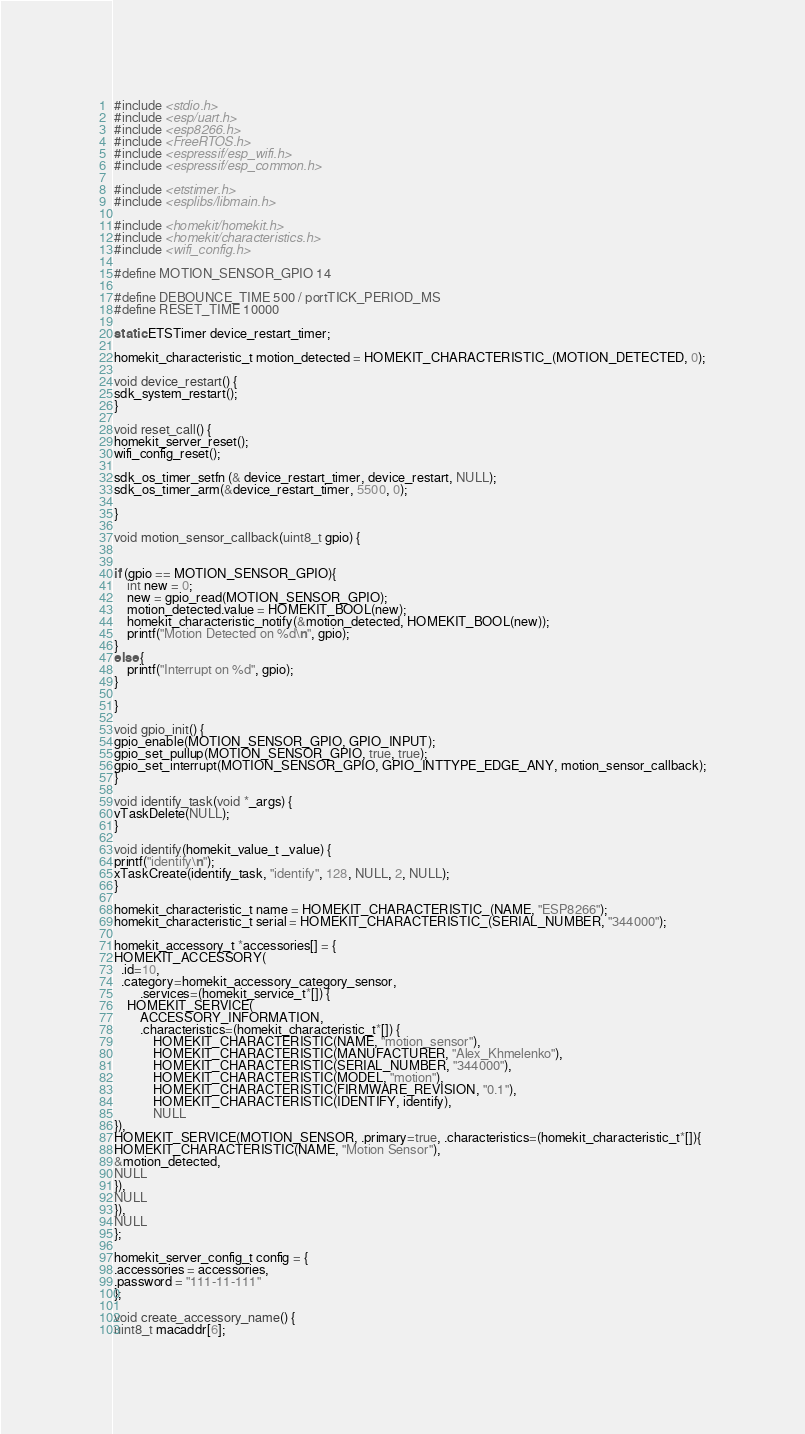Convert code to text. <code><loc_0><loc_0><loc_500><loc_500><_C_>#include <stdio.h>
#include <esp/uart.h>
#include <esp8266.h>
#include <FreeRTOS.h>
#include <espressif/esp_wifi.h>
#include <espressif/esp_common.h>

#include <etstimer.h>
#include <esplibs/libmain.h>

#include <homekit/homekit.h>
#include <homekit/characteristics.h>
#include <wifi_config.h>

#define MOTION_SENSOR_GPIO 14

#define DEBOUNCE_TIME 500 / portTICK_PERIOD_MS
#define RESET_TIME 10000

static ETSTimer device_restart_timer;

homekit_characteristic_t motion_detected = HOMEKIT_CHARACTERISTIC_(MOTION_DETECTED, 0);

void device_restart() {
sdk_system_restart();
}

void reset_call() {
homekit_server_reset();
wifi_config_reset();

sdk_os_timer_setfn (& device_restart_timer, device_restart, NULL);
sdk_os_timer_arm(&device_restart_timer, 5500, 0);

}

void motion_sensor_callback(uint8_t gpio) {


if (gpio == MOTION_SENSOR_GPIO){
    int new = 0;
    new = gpio_read(MOTION_SENSOR_GPIO);
    motion_detected.value = HOMEKIT_BOOL(new);
    homekit_characteristic_notify(&motion_detected, HOMEKIT_BOOL(new));
    printf("Motion Detected on %d\n", gpio);
}
else {
    printf("Interrupt on %d", gpio);
}

}

void gpio_init() {
gpio_enable(MOTION_SENSOR_GPIO, GPIO_INPUT);
gpio_set_pullup(MOTION_SENSOR_GPIO, true, true);
gpio_set_interrupt(MOTION_SENSOR_GPIO, GPIO_INTTYPE_EDGE_ANY, motion_sensor_callback);
}

void identify_task(void *_args) {
vTaskDelete(NULL);
}

void identify(homekit_value_t _value) {
printf("identify\n");
xTaskCreate(identify_task, "identify", 128, NULL, 2, NULL);
}

homekit_characteristic_t name = HOMEKIT_CHARACTERISTIC_(NAME, "ESP8266");
homekit_characteristic_t serial = HOMEKIT_CHARACTERISTIC_(SERIAL_NUMBER, "344000");

homekit_accessory_t *accessories[] = {
HOMEKIT_ACCESSORY(
  .id=10,
  .category=homekit_accessory_category_sensor,
        .services=(homekit_service_t*[]) {
    HOMEKIT_SERVICE(
        ACCESSORY_INFORMATION,
        .characteristics=(homekit_characteristic_t*[]) {
            HOMEKIT_CHARACTERISTIC(NAME, "motion_sensor"),
            HOMEKIT_CHARACTERISTIC(MANUFACTURER, "Alex_Khmelenko"),
            HOMEKIT_CHARACTERISTIC(SERIAL_NUMBER, "344000"),
            HOMEKIT_CHARACTERISTIC(MODEL, "motion"),
            HOMEKIT_CHARACTERISTIC(FIRMWARE_REVISION, "0.1"),
            HOMEKIT_CHARACTERISTIC(IDENTIFY, identify),
            NULL
}),
HOMEKIT_SERVICE(MOTION_SENSOR, .primary=true, .characteristics=(homekit_characteristic_t*[]){
HOMEKIT_CHARACTERISTIC(NAME, "Motion Sensor"),
&motion_detected,
NULL
}),
NULL
}),
NULL
};

homekit_server_config_t config = {
.accessories = accessories,
.password = "111-11-111"
};

void create_accessory_name() {
uint8_t macaddr[6];</code> 